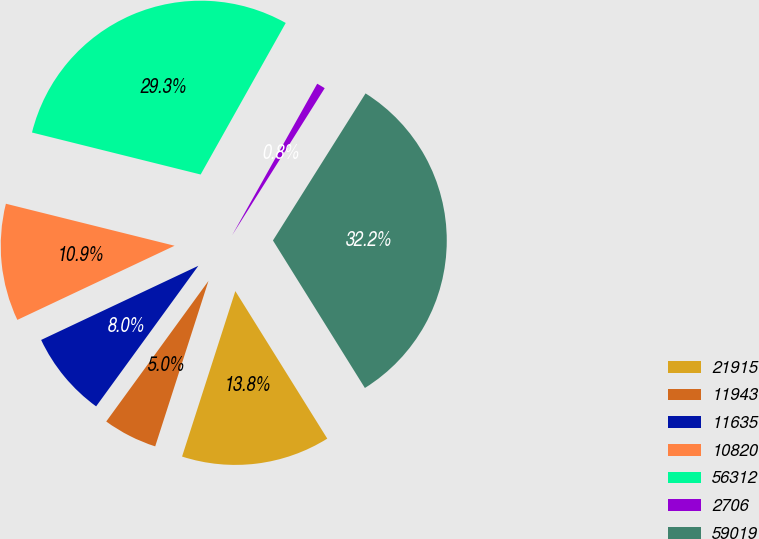Convert chart to OTSL. <chart><loc_0><loc_0><loc_500><loc_500><pie_chart><fcel>21915<fcel>11943<fcel>11635<fcel>10820<fcel>56312<fcel>2706<fcel>59019<nl><fcel>13.83%<fcel>5.05%<fcel>7.98%<fcel>10.9%<fcel>29.26%<fcel>0.8%<fcel>32.19%<nl></chart> 